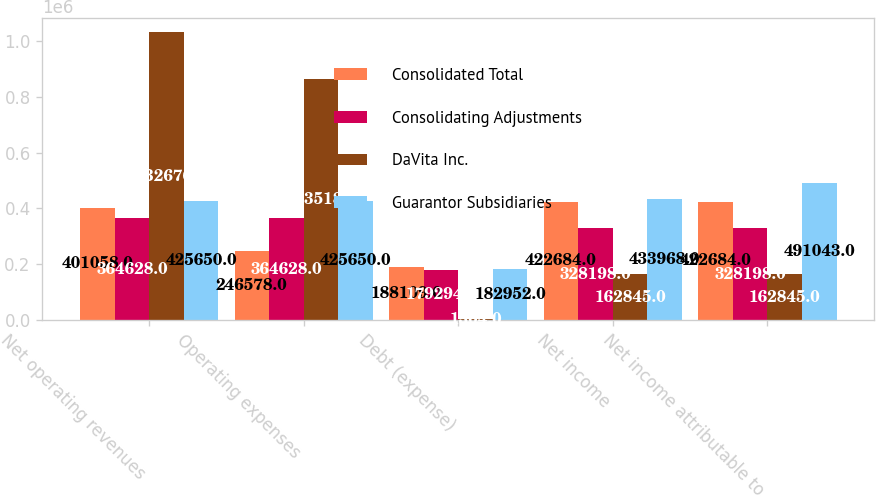<chart> <loc_0><loc_0><loc_500><loc_500><stacked_bar_chart><ecel><fcel>Net operating revenues<fcel>Operating expenses<fcel>Debt (expense)<fcel>Net income<fcel>Net income attributable to<nl><fcel>Consolidated Total<fcel>401058<fcel>246578<fcel>188109<fcel>422684<fcel>422684<nl><fcel>Consolidating Adjustments<fcel>364628<fcel>364628<fcel>179294<fcel>328198<fcel>328198<nl><fcel>DaVita Inc.<fcel>1.03268e+06<fcel>863518<fcel>1304<fcel>162845<fcel>162845<nl><fcel>Guarantor Subsidiaries<fcel>425650<fcel>425650<fcel>182952<fcel>433968<fcel>491043<nl></chart> 